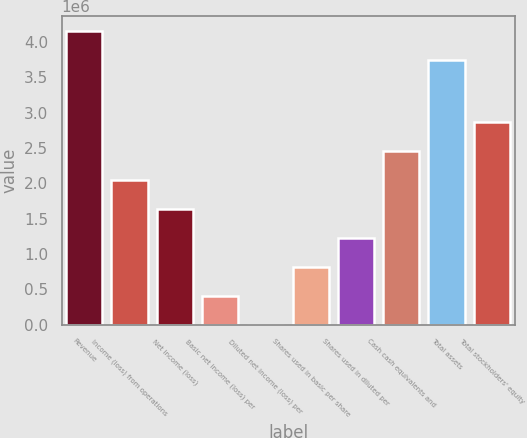Convert chart. <chart><loc_0><loc_0><loc_500><loc_500><bar_chart><fcel>Revenue<fcel>Income (loss) from operations<fcel>Net income (loss)<fcel>Basic net income (loss) per<fcel>Diluted net income (loss) per<fcel>Shares used in basic per share<fcel>Shares used in diluted per<fcel>Cash cash equivalents and<fcel>Total assets<fcel>Total stockholders' equity<nl><fcel>4.15746e+06<fcel>2.04893e+06<fcel>1.63914e+06<fcel>409787<fcel>1.31<fcel>819573<fcel>1.22936e+06<fcel>2.45872e+06<fcel>3.74767e+06<fcel>2.8685e+06<nl></chart> 